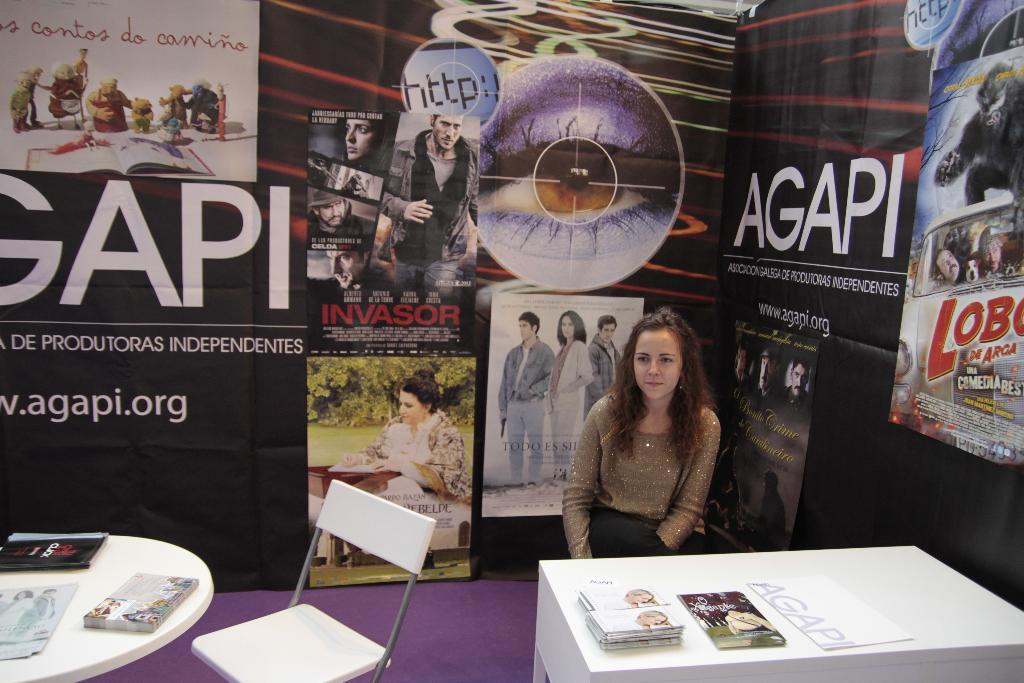What type of furniture is present in the image? There is a chair and a table in the image. What is placed on the table? There are books on the table. Is there any decoration or additional element in the background? Yes, there is a banner at the back side of the image. Can you hear the band playing in the image? There is no band present in the image, so it is not possible to hear any music. 